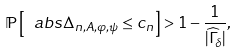<formula> <loc_0><loc_0><loc_500><loc_500>\mathbb { P } \left [ \ a b s { \Delta _ { n , A , \varphi , \psi } } \leq c _ { n } \right ] > 1 - \frac { 1 } { | \widehat { \Gamma } _ { \delta } | } ,</formula> 